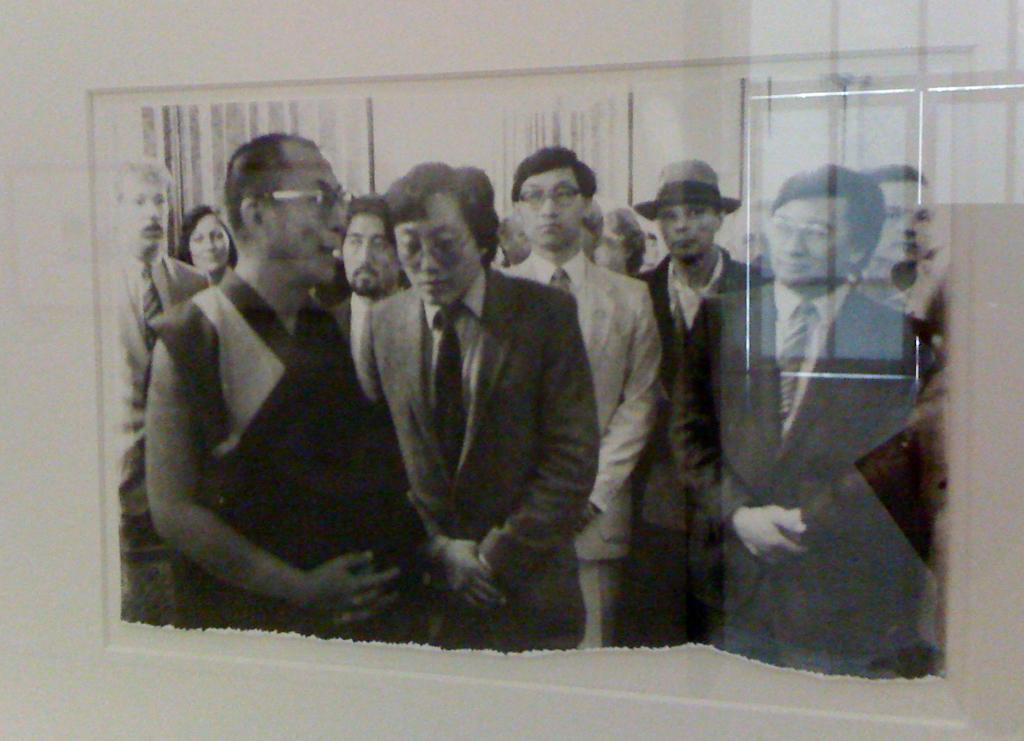How many people are in the image? There are multiple persons in the image. Can you describe the attire of one of the persons? One of the persons is wearing a hat. How close are the persons standing to each other? The persons are standing close to each other. What type of animal can be seen in the cemetery in the image? There is no animal or cemetery present in the image; it features multiple persons standing close to each other. 